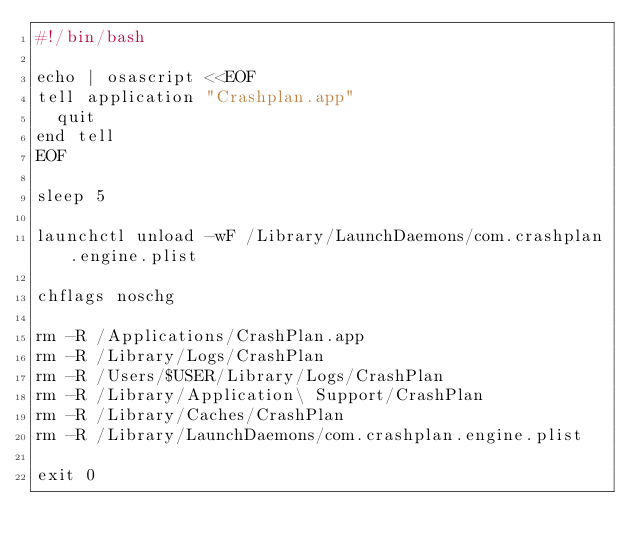<code> <loc_0><loc_0><loc_500><loc_500><_Bash_>#!/bin/bash

echo | osascript <<EOF
tell application "Crashplan.app"
  quit
end tell
EOF

sleep 5

launchctl unload -wF /Library/LaunchDaemons/com.crashplan.engine.plist

chflags noschg

rm -R /Applications/CrashPlan.app
rm -R /Library/Logs/CrashPlan
rm -R /Users/$USER/Library/Logs/CrashPlan
rm -R /Library/Application\ Support/CrashPlan
rm -R /Library/Caches/CrashPlan
rm -R /Library/LaunchDaemons/com.crashplan.engine.plist

exit 0
</code> 